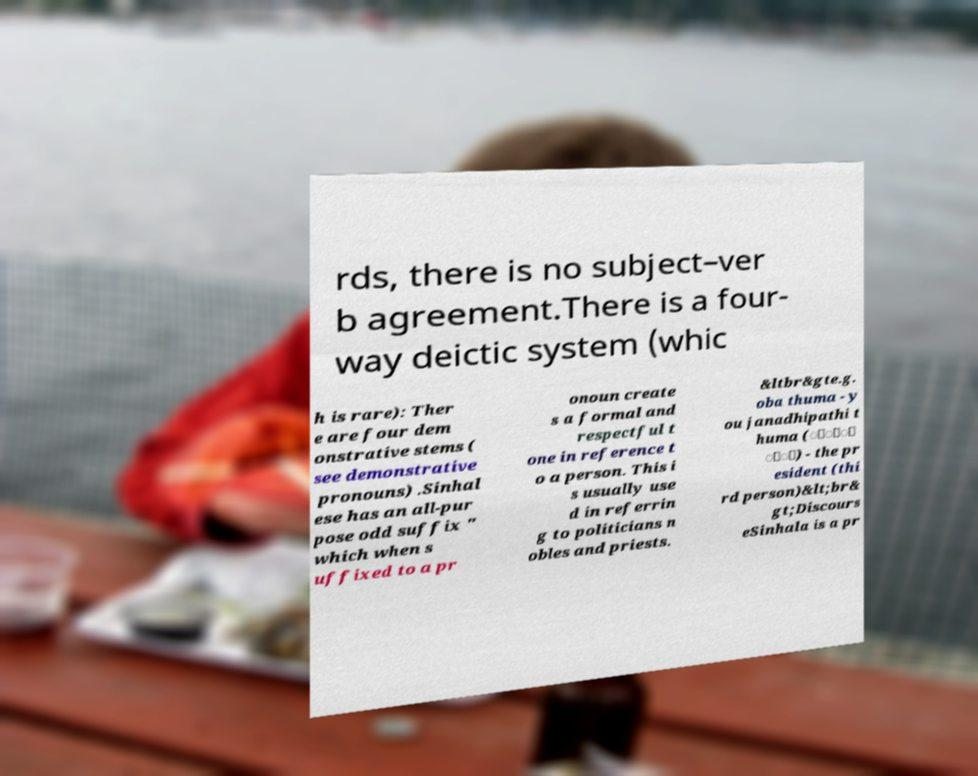Could you assist in decoding the text presented in this image and type it out clearly? rds, there is no subject–ver b agreement.There is a four- way deictic system (whic h is rare): Ther e are four dem onstrative stems ( see demonstrative pronouns) .Sinhal ese has an all-pur pose odd suffix " which when s uffixed to a pr onoun create s a formal and respectful t one in reference t o a person. This i s usually use d in referrin g to politicians n obles and priests. &ltbr&gte.g. oba thuma - y ou janadhipathi t huma (ාිි ුා) - the pr esident (thi rd person)&lt;br& gt;Discours eSinhala is a pr 